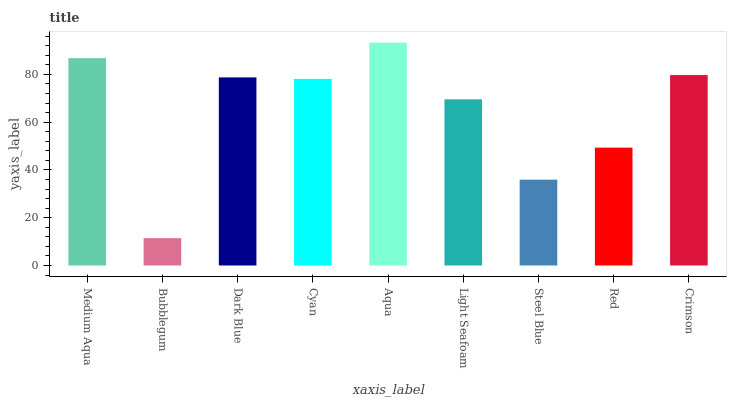Is Bubblegum the minimum?
Answer yes or no. Yes. Is Aqua the maximum?
Answer yes or no. Yes. Is Dark Blue the minimum?
Answer yes or no. No. Is Dark Blue the maximum?
Answer yes or no. No. Is Dark Blue greater than Bubblegum?
Answer yes or no. Yes. Is Bubblegum less than Dark Blue?
Answer yes or no. Yes. Is Bubblegum greater than Dark Blue?
Answer yes or no. No. Is Dark Blue less than Bubblegum?
Answer yes or no. No. Is Cyan the high median?
Answer yes or no. Yes. Is Cyan the low median?
Answer yes or no. Yes. Is Bubblegum the high median?
Answer yes or no. No. Is Bubblegum the low median?
Answer yes or no. No. 